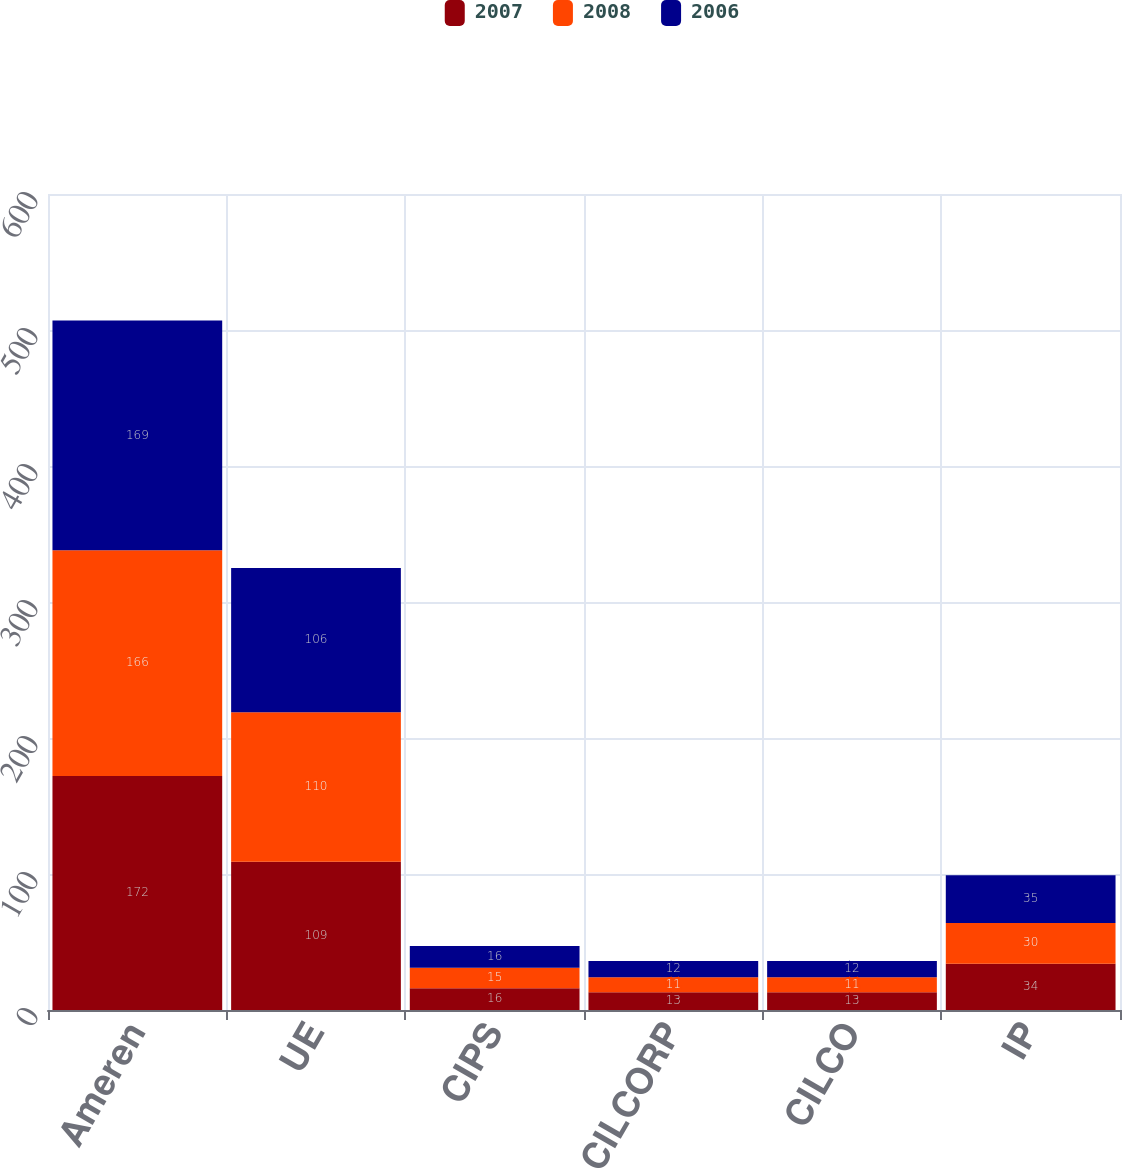Convert chart to OTSL. <chart><loc_0><loc_0><loc_500><loc_500><stacked_bar_chart><ecel><fcel>Ameren<fcel>UE<fcel>CIPS<fcel>CILCORP<fcel>CILCO<fcel>IP<nl><fcel>2007<fcel>172<fcel>109<fcel>16<fcel>13<fcel>13<fcel>34<nl><fcel>2008<fcel>166<fcel>110<fcel>15<fcel>11<fcel>11<fcel>30<nl><fcel>2006<fcel>169<fcel>106<fcel>16<fcel>12<fcel>12<fcel>35<nl></chart> 